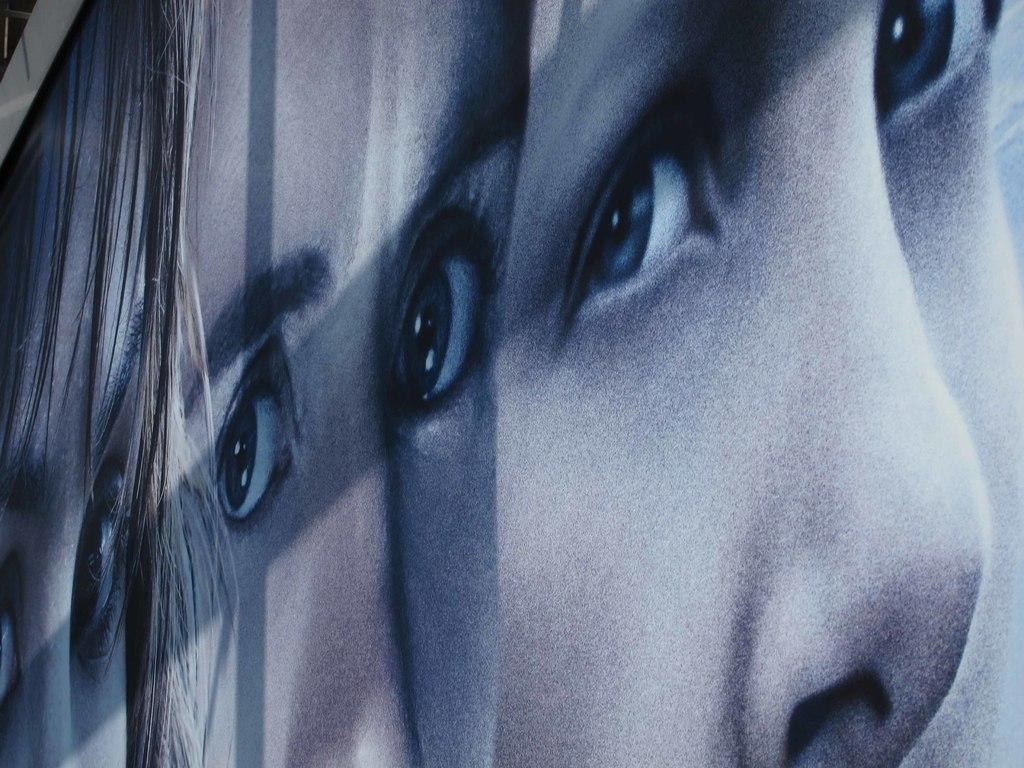Who is present in the image? There is a girl in the image. What type of volcano can be seen erupting in the background of the image? There is no volcano present in the image; it only features a girl. What is the nature of the argument taking place between the girl and another person in the image? There is no argument or other person present in the image; it only features a girl. 